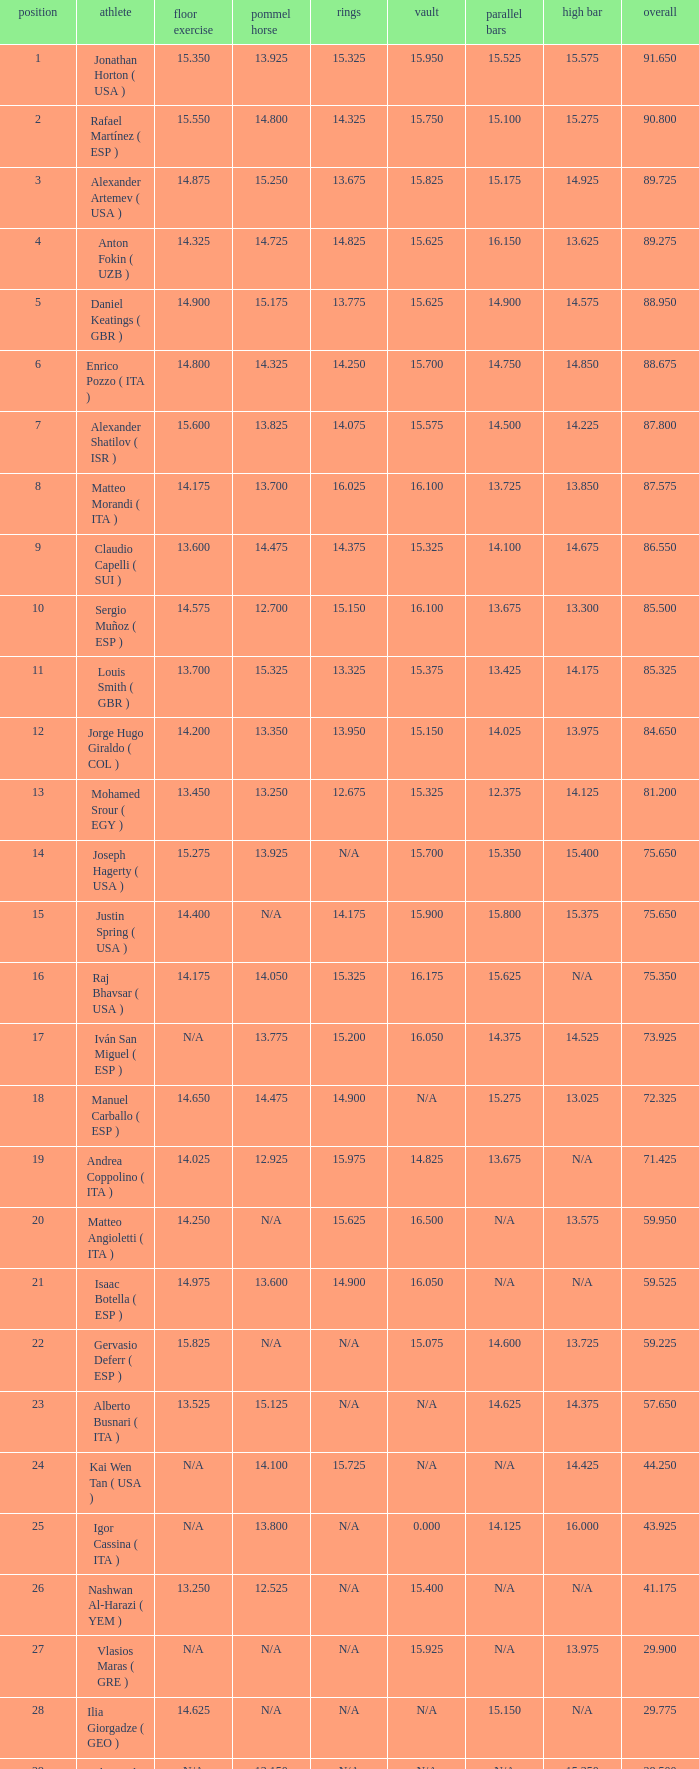If the floor digit is 1 14.025. 